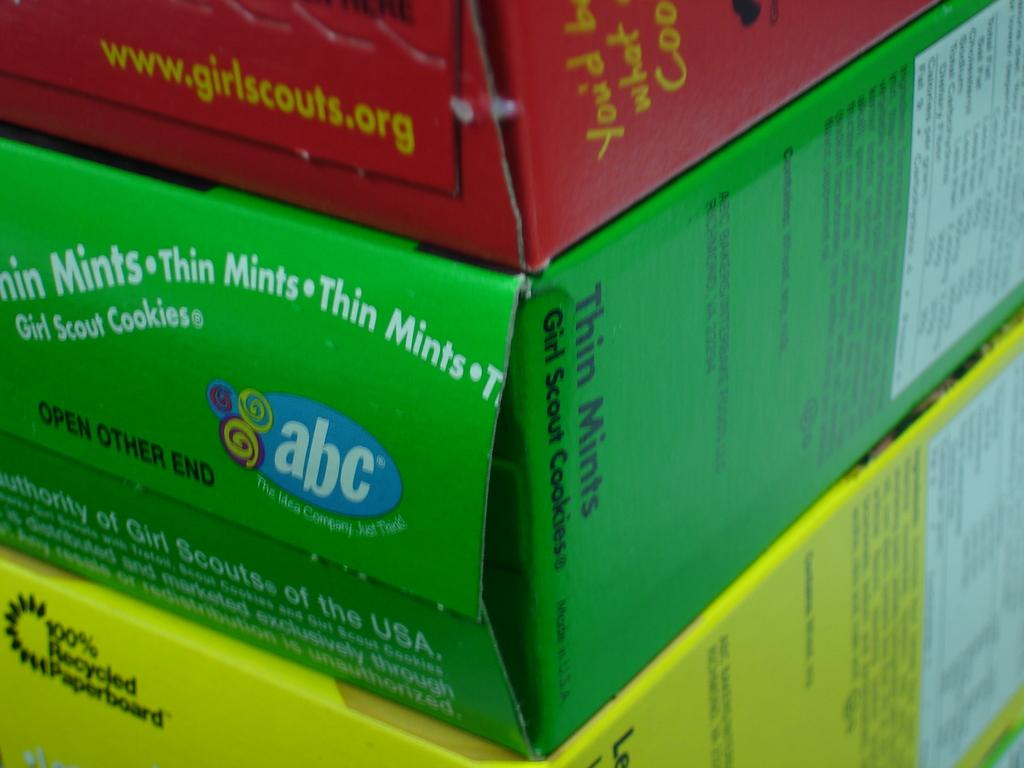<image>
Provide a brief description of the given image. The sides of several different kinds of Girl Scout cookies. 